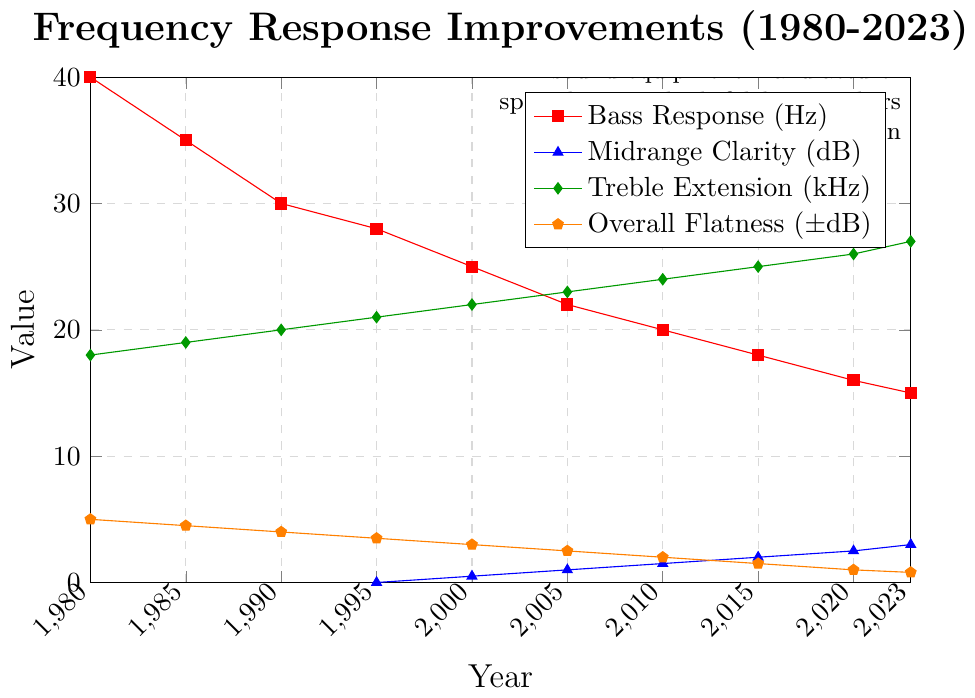What was the Bass Response in 2000? Refer to the red line marked with squares and find the corresponding value for the year 2000 on the x-axis.
Answer: 25 Hz Between which years did the Midrange Clarity improve from -1 dB to 2 dB? Track the blue line marked with triangles and identify the years at which the values change from -1 dB to 2 dB on the y-axis.
Answer: 1990 to 2015 What is the difference in Overall Flatness between 1985 and 2023? Locate the orange line marked with pentagons at years 1985 and 2023. The values are 4.5 dB and 0.8 dB respectively. Subtract 0.8 from 4.5.
Answer: 3.7 dB In what year did the Treble Extension reach 23 kHz? Follow the green line marked with diamonds and find the year where the value on the y-axis is 23 kHz.
Answer: 2005 How much did the Bass Response improve between 1980 and 2023? Identify the values of the Bass Response in 1980 and 2023 on the red line. The values are 40 Hz and 15 Hz respectively. Subtract 15 from 40.
Answer: 25 Hz Which parameter showed the most improvement in average value from 1980 to 2023? Average the starting and ending values for Bass Response, Midrange Clarity, Treble Extension, and Overall Flatness:
- Bass Response: (40+15)/2 = 27.5 Hz
- Midrange Clarity: (-3+3)/2 = 0 dB
- Treble Extension: (18+27)/2 = 22.5 kHz
- Overall Flatness: (5+0.8)/2 = 2.9 dB
Answer: Treble Extension How does the Midrange Clarity in 2010 compare to that in 1980? Observing the blue line, Midrange Clarity was -3 dB in 1980 and 1.5 dB in 2010. This is an improvement.
Answer: Improved by 4.5 dB Which year saw the smallest change in Treble Extension compared to the previous year? Calculate the yearly change in Treble Extension for each interval, and identify the smallest change:
- 1985-1980 = 1 kHz
- 1990-1985 = 1 kHz
- 1995-1990 = 1 kHz
- 2000-1995 = 1 kHz
- 2005-2000 = 1 kHz
- 2010-2005 = 1 kHz
- 2015-2010 = 1 kHz
- 2020-2015 = 1 kHz
- 2023-2020 = 1 kHz
Answer: All changes are equal 